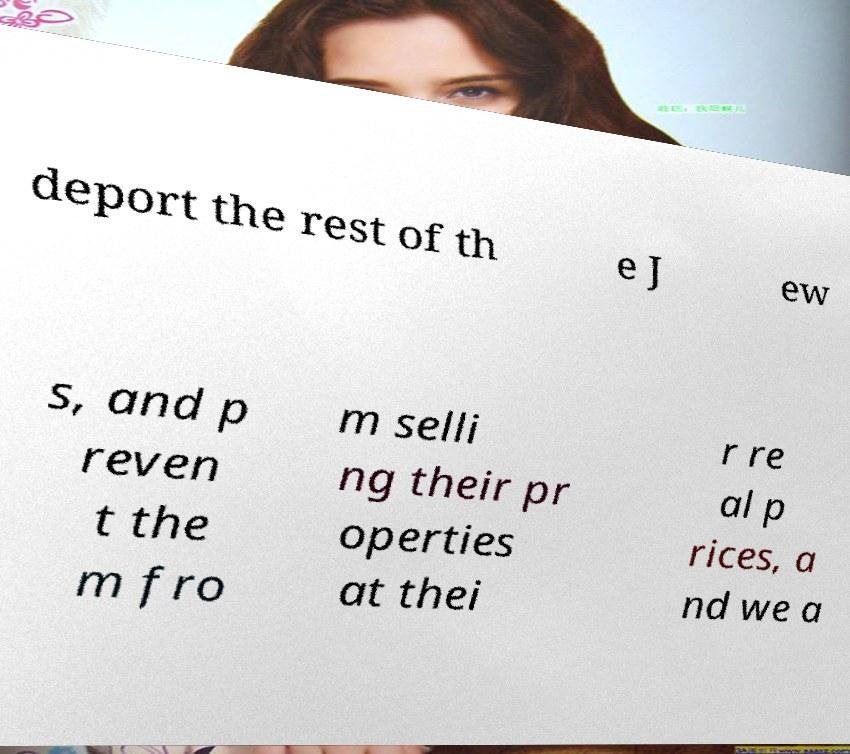Please read and relay the text visible in this image. What does it say? deport the rest of th e J ew s, and p reven t the m fro m selli ng their pr operties at thei r re al p rices, a nd we a 